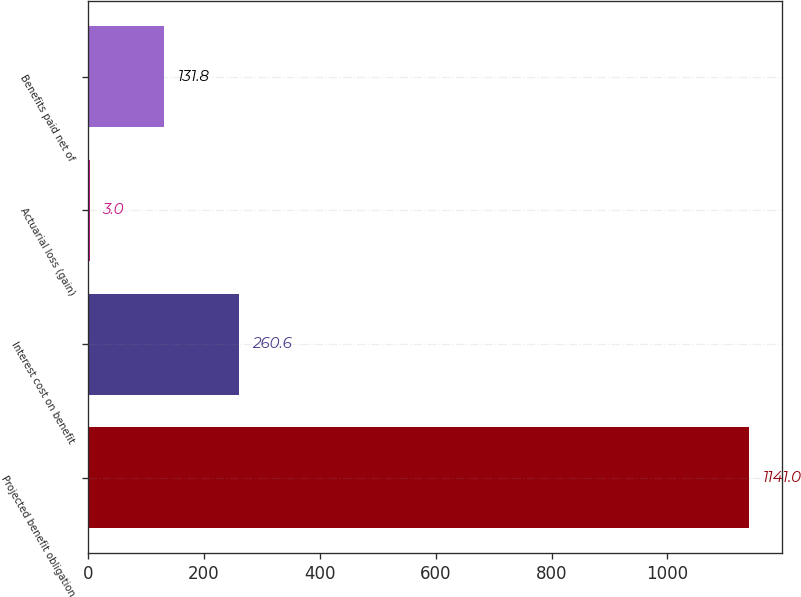Convert chart to OTSL. <chart><loc_0><loc_0><loc_500><loc_500><bar_chart><fcel>Projected benefit obligation<fcel>Interest cost on benefit<fcel>Actuarial loss (gain)<fcel>Benefits paid net of<nl><fcel>1141<fcel>260.6<fcel>3<fcel>131.8<nl></chart> 